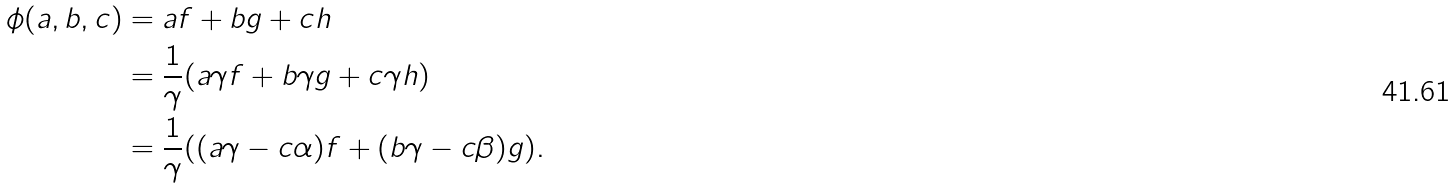<formula> <loc_0><loc_0><loc_500><loc_500>\phi ( a , b , c ) & = a f + b g + c h \\ & = \frac { 1 } { \gamma } ( a \gamma f + b \gamma g + c \gamma h ) \\ & = \frac { 1 } { \gamma } ( ( a \gamma - c \alpha ) f + ( b \gamma - c \beta ) g ) .</formula> 